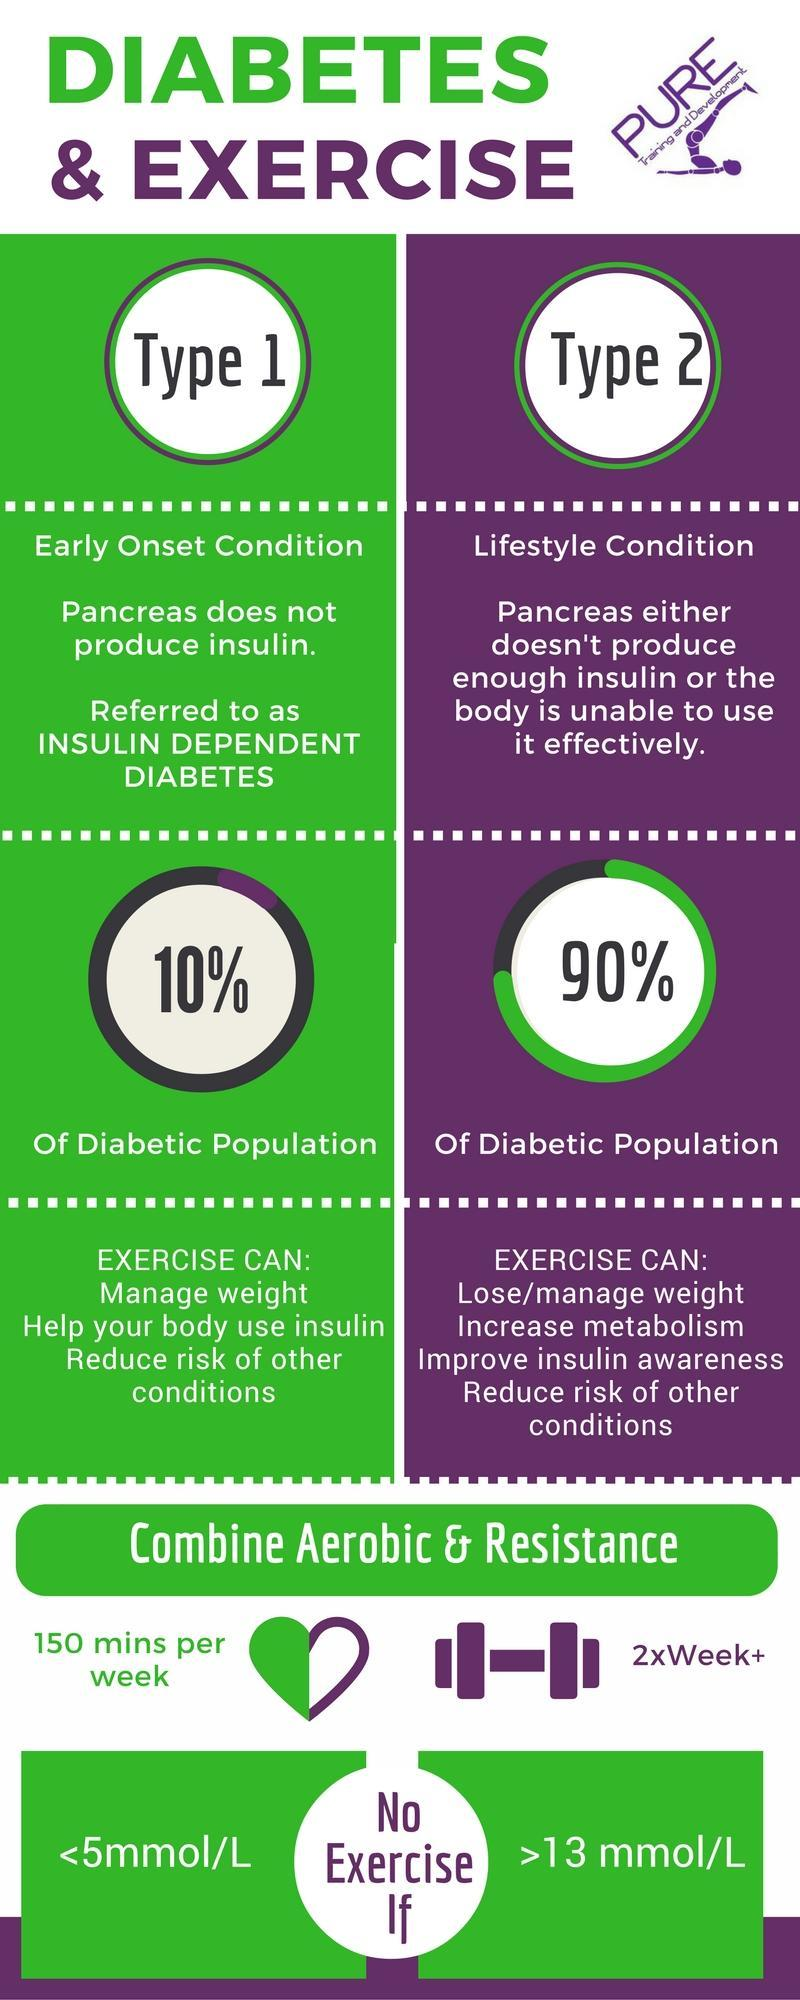Give the percentage of diabetic population that exercise can guarantee risk reduction of other conditions.
Answer the question with a short phrase. 100% Which is the organ associated with insulin? Pancreas Which are the two exercises that can help control diabetes? Aerobic, Resistance What is the main contributing factor for Type 2 diabetes? Lifestyle What are the variants of diabetes discussed here? Type 1, Type 2 